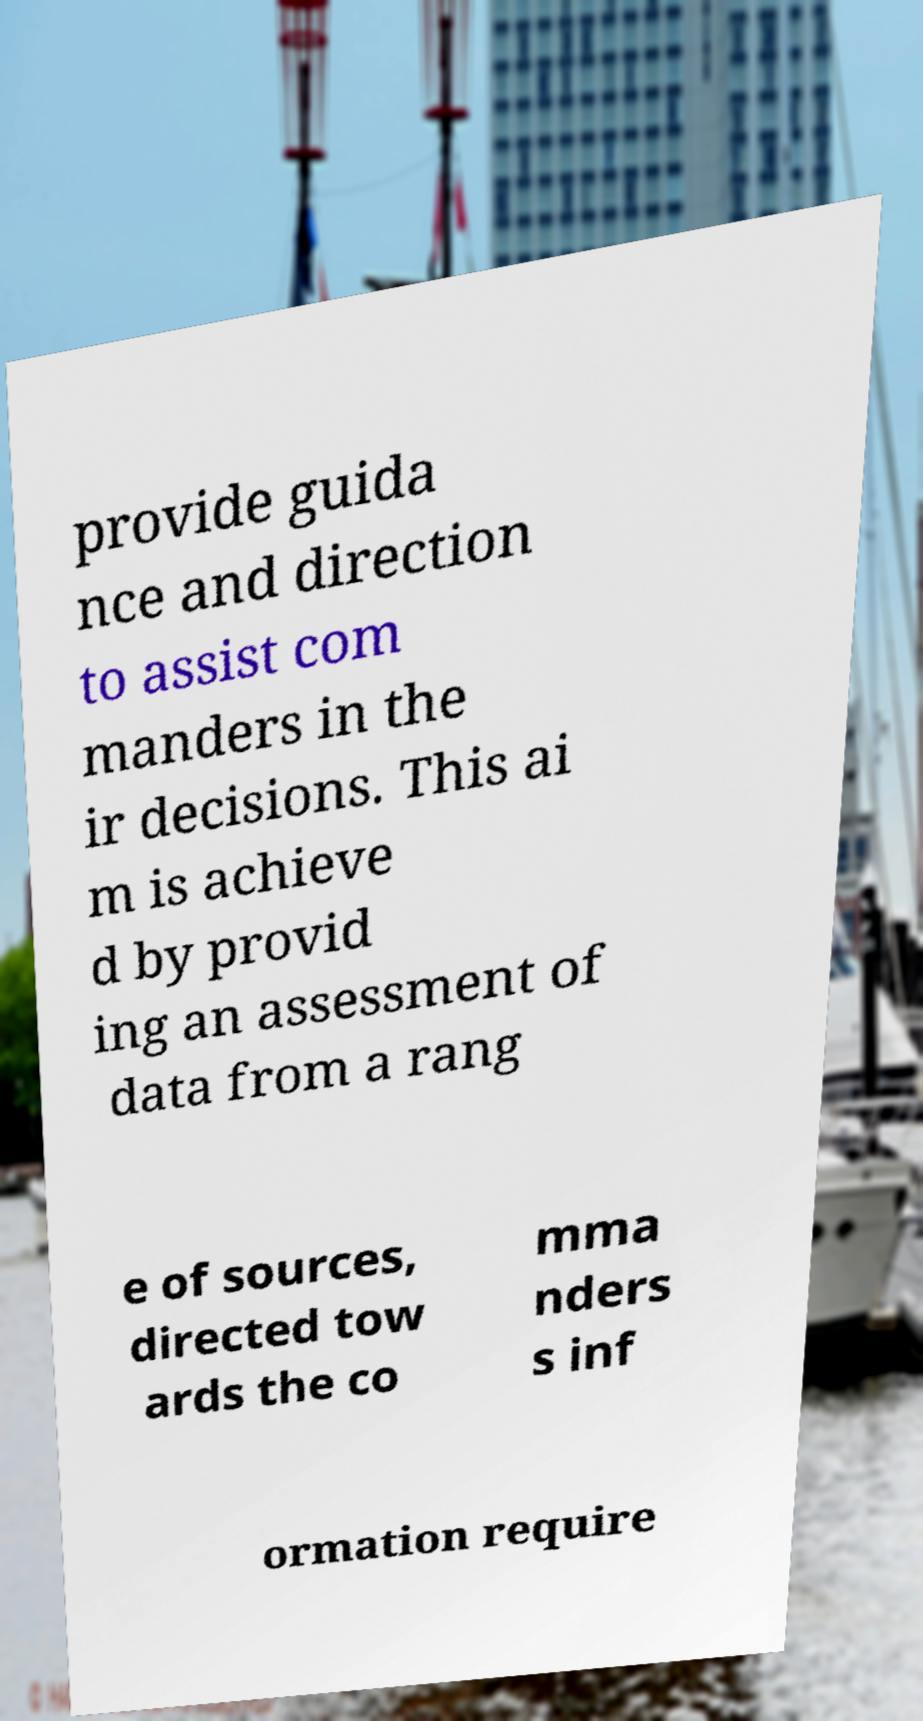Can you read and provide the text displayed in the image?This photo seems to have some interesting text. Can you extract and type it out for me? provide guida nce and direction to assist com manders in the ir decisions. This ai m is achieve d by provid ing an assessment of data from a rang e of sources, directed tow ards the co mma nders s inf ormation require 